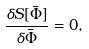<formula> <loc_0><loc_0><loc_500><loc_500>\frac { \delta S [ \bar { \Phi } ] } { \delta \bar { \Phi } } = 0 ,</formula> 